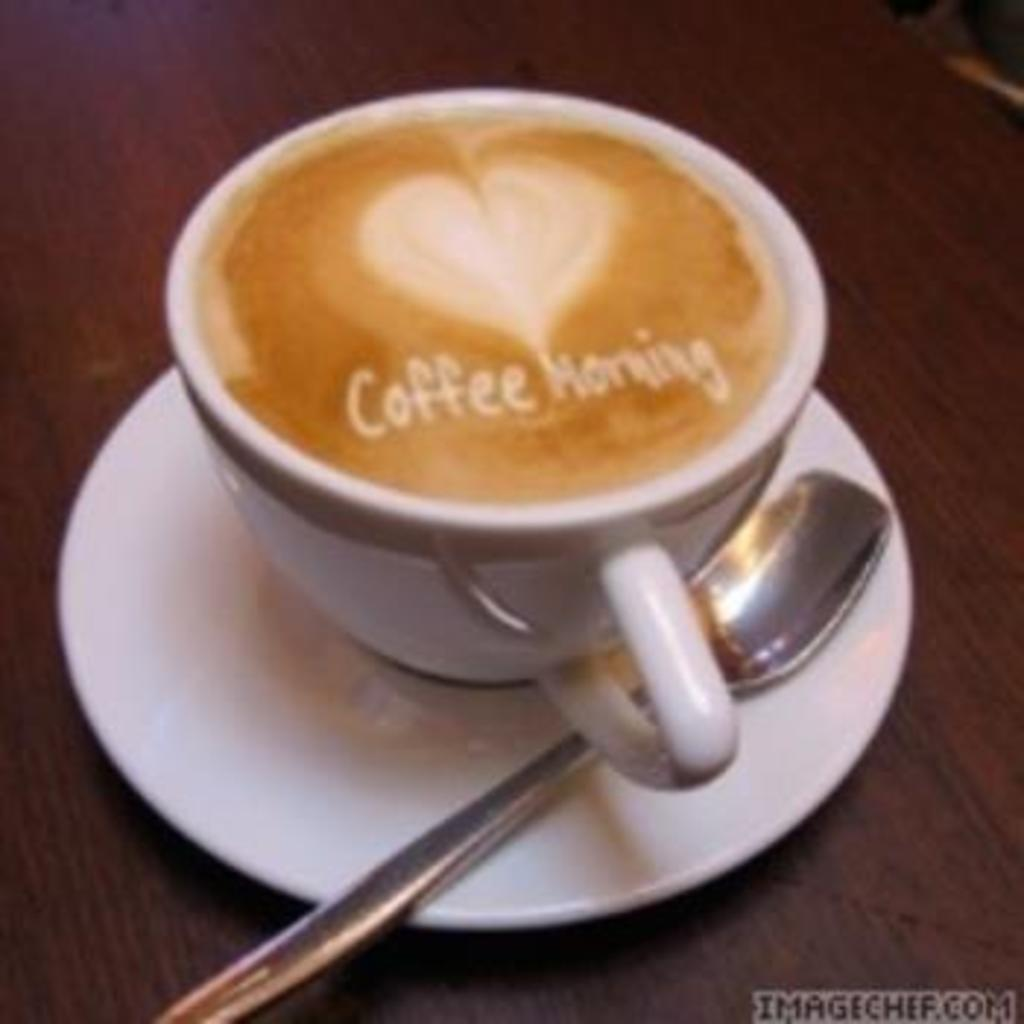What is in the cup that is visible in the image? There is coffee in a cup in the image. What utensil is present in the image? There is a spoon in the image. What is the spoon resting on? There is a saucer in the image, which the spoon is resting on. What surface is the coffee cup and saucer placed on? There is a table in the image. What additional information can be found at the bottom of the image? There is some text visible at the bottom of the image. Are there any ants crawling on the table in the image? There is no indication of ants or any other insects in the image. What is the temper of the person who wrote the text visible at the bottom of the image? The image does not provide any information about the temper of the person who wrote the text. 